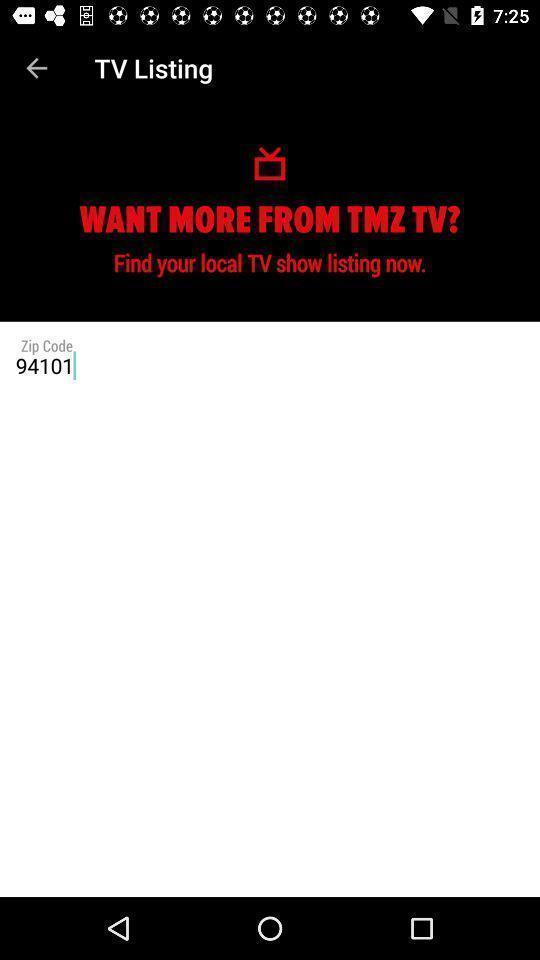Summarize the main components in this picture. Page displaying tv shows information. 